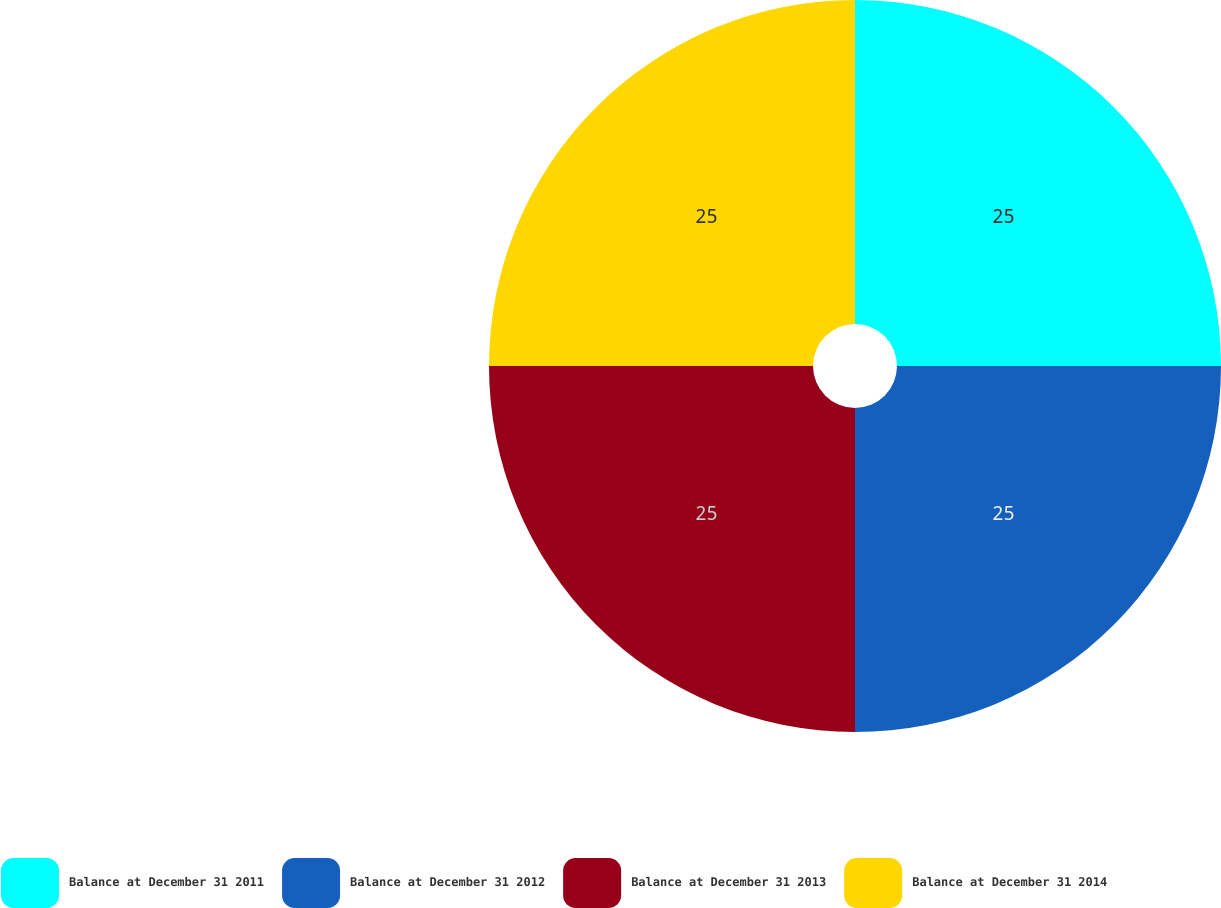<chart> <loc_0><loc_0><loc_500><loc_500><pie_chart><fcel>Balance at December 31 2011<fcel>Balance at December 31 2012<fcel>Balance at December 31 2013<fcel>Balance at December 31 2014<nl><fcel>25.0%<fcel>25.0%<fcel>25.0%<fcel>25.0%<nl></chart> 